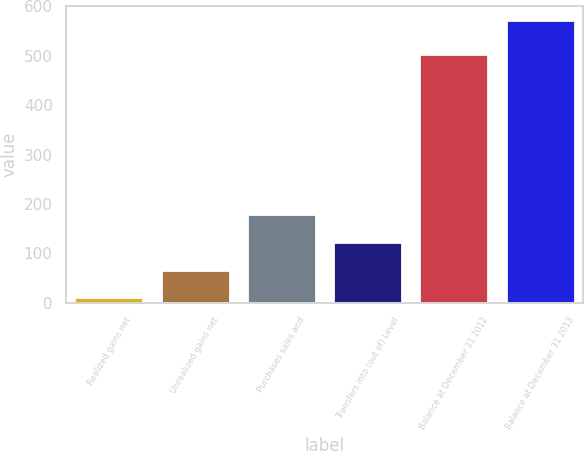Convert chart. <chart><loc_0><loc_0><loc_500><loc_500><bar_chart><fcel>Realized gains net<fcel>Unrealized gains net<fcel>Purchases sales and<fcel>Transfers into (out of) Level<fcel>Balance at December 31 2012<fcel>Balance at December 31 2013<nl><fcel>11<fcel>67.1<fcel>179.3<fcel>123.2<fcel>504<fcel>572<nl></chart> 